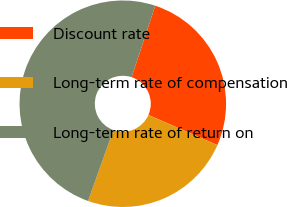Convert chart to OTSL. <chart><loc_0><loc_0><loc_500><loc_500><pie_chart><fcel>Discount rate<fcel>Long-term rate of compensation<fcel>Long-term rate of return on<nl><fcel>26.47%<fcel>23.9%<fcel>49.63%<nl></chart> 